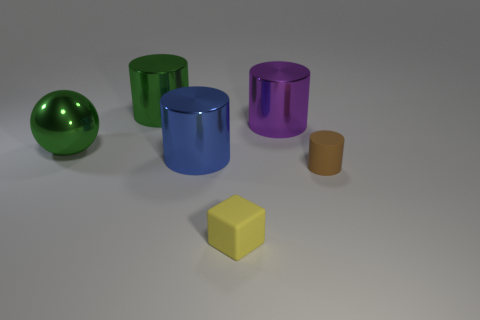How many big cylinders have the same color as the metal ball?
Offer a terse response. 1. There is a shiny thing that is on the left side of the big green cylinder; is its color the same as the matte thing that is to the right of the small yellow matte object?
Your answer should be very brief. No. Are there any green shiny things that are in front of the shiny cylinder that is on the left side of the large blue metal cylinder?
Your response must be concise. Yes. Are there fewer green metal spheres on the right side of the large purple metal cylinder than blue cylinders in front of the cube?
Give a very brief answer. No. Do the object that is on the right side of the purple shiny thing and the green cylinder that is on the right side of the ball have the same material?
Give a very brief answer. No. How many tiny objects are green objects or green spheres?
Keep it short and to the point. 0. What is the shape of the big purple thing that is the same material as the green ball?
Provide a succinct answer. Cylinder. Is the number of small brown things that are to the left of the cube less than the number of big blue metallic objects?
Your answer should be compact. Yes. Does the brown object have the same shape as the small yellow matte thing?
Your response must be concise. No. How many matte objects are either large purple cylinders or green spheres?
Provide a short and direct response. 0. 